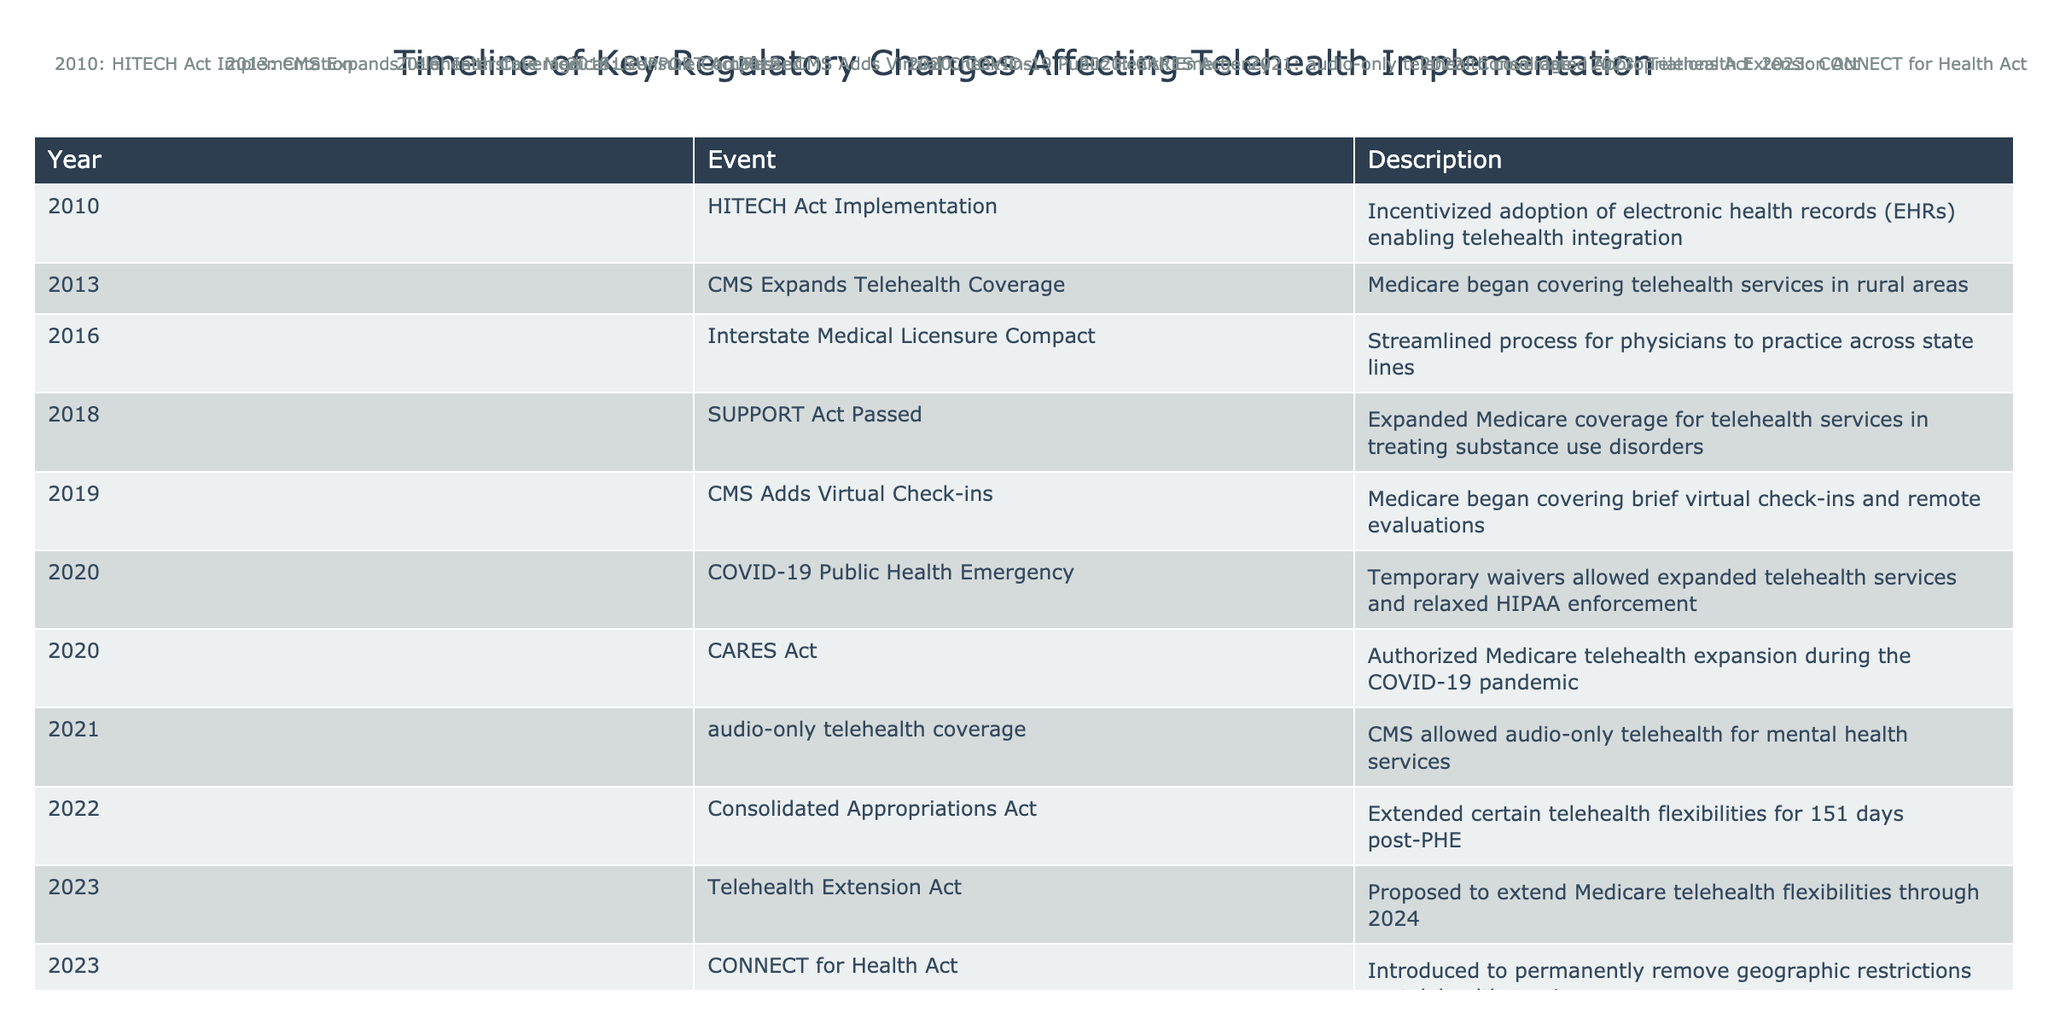What year was the COVID-19 Public Health Emergency declared? The table shows that the COVID-19 Public Health Emergency occurred in 2020.
Answer: 2020 Which event allowed Medicare to cover telehealth for treating substance use disorders? The SUPPORT Act passed in 2018 expanded Medicare coverage specifically for telehealth services related to substance use disorders.
Answer: SUPPORT Act Passed How many events were related to Medicare coverage changes between 2010 and 2023? There are five events where Medicare coverage changes were mentioned: 2013 (expands coverage), 2018 (supports substance use), 2019 (virtual check-ins), 2020 (expansion due to COVID-19), and 2021 (audio-only services). Thus, the total is 5.
Answer: 5 Was the Interstate Medical Licensure Compact established before or after the SUPPORT Act? The Interstate Medical Licensure Compact was established in 2016, while the SUPPORT Act came into effect in 2018. Therefore, the compact was created prior to the SUPPORT Act.
Answer: Before What is the total number of years between the HITECH Act Implementation and the introduction of the CONNECT for Health Act? The HITECH Act Implementation occurred in 2010, and the CONNECT for Health Act was introduced in 2023. To find the difference, subtract 2010 from 2023, which equals 13 years.
Answer: 13 years Did the 2022 Consolidated Appropriations Act extend telehealth flexibilities for a period longer than one year? The 2022 Consolidated Appropriations Act extended certain telehealth flexibilities for just 151 days post-public health emergency, which is significantly less than one year.
Answer: No What major event allowed for significant changes to telehealth regulations in 2020? The COVID-19 Public Health Emergency caused major changes, with temporary waivers that allowed expanded telehealth services and relaxed HIPAA enforcement. The CARES Act also authorized Medicare's telehealth expansion due to this event.
Answer: COVID-19 Public Health Emergency How many total key regulatory changes were listed in the table from 2010 to 2023? By counting each of the individual events listed from 2010 to 2023, there are a total of 10 key regulatory changes noted in the table.
Answer: 10 